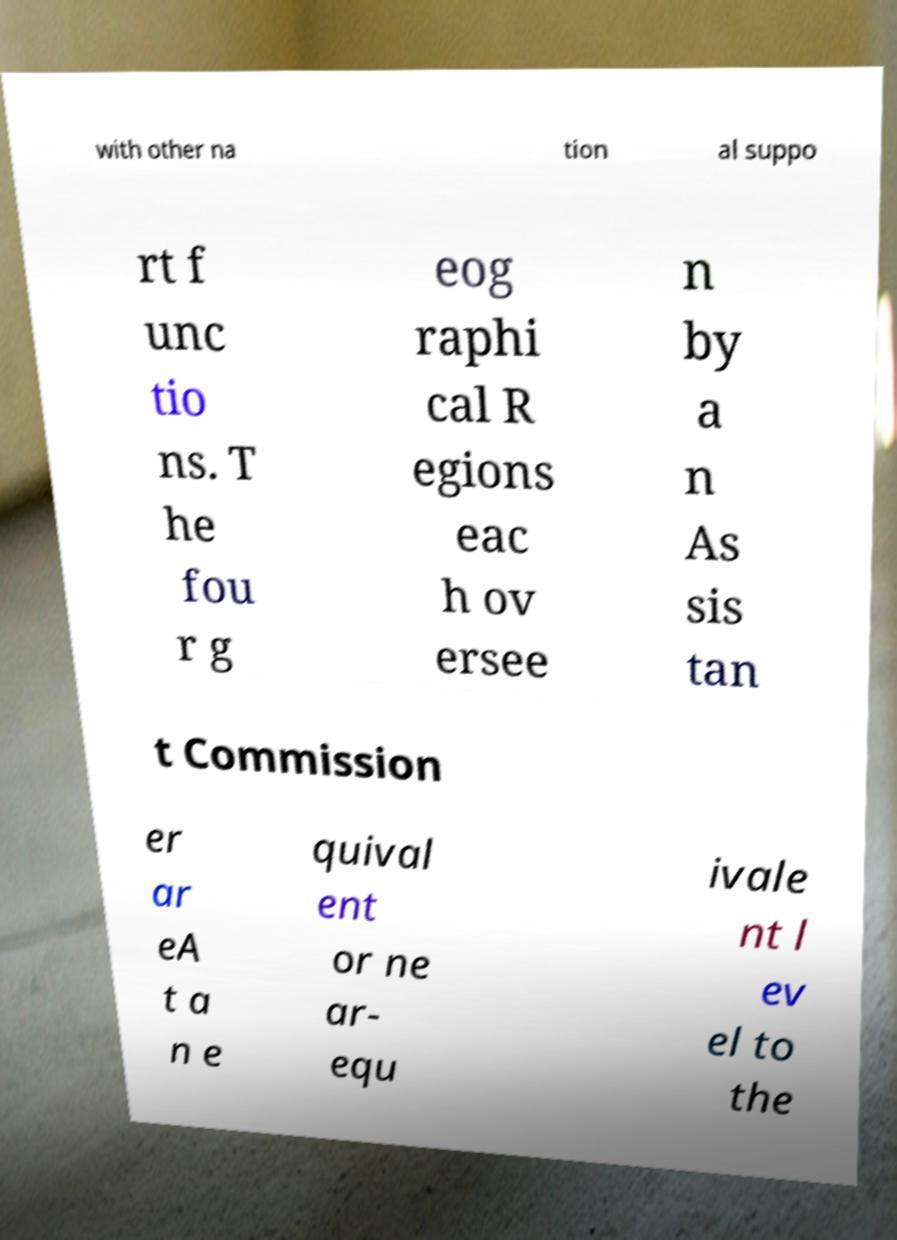What messages or text are displayed in this image? I need them in a readable, typed format. with other na tion al suppo rt f unc tio ns. T he fou r g eog raphi cal R egions eac h ov ersee n by a n As sis tan t Commission er ar eA t a n e quival ent or ne ar- equ ivale nt l ev el to the 